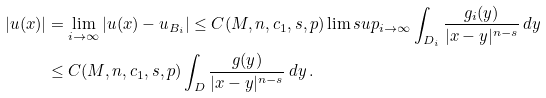<formula> <loc_0><loc_0><loc_500><loc_500>| u ( x ) | & = \lim _ { i \to \infty } | u ( x ) - u _ { B _ { i } } | \leq C ( M , n , c _ { 1 } , s , p ) \lim s u p _ { i \to \infty } \int _ { D _ { i } } \frac { g _ { i } ( y ) } { | x - y | ^ { n - s } } \, d y \\ & \leq C ( M , n , c _ { 1 } , s , p ) \int _ { D } \frac { g ( y ) } { | x - y | ^ { n - s } } \, d y \, .</formula> 